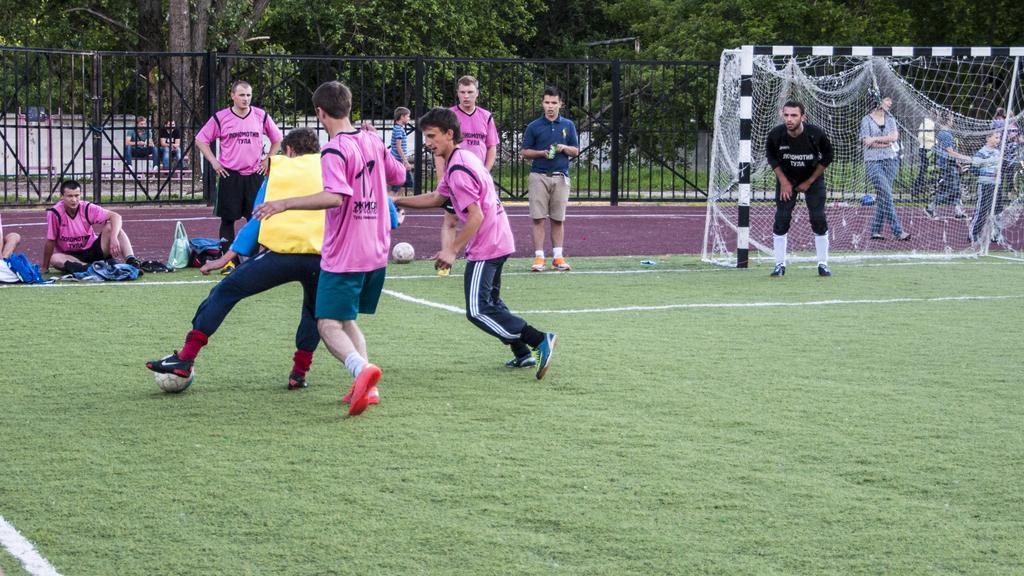What activity are the persons in the image engaged in? The persons in the image are playing football. What is the surface they are playing on? The playing surface is grass. What can be seen at each end of the field? There is a mesh in the image, likely a goal. What can be seen in the background of the image? There are trees and a fence visible in the background. What type of magic is being performed by the players in the image? There is no magic being performed in the image; the persons are playing football. Can you describe the facial expressions of the players in the image? The provided facts do not mention the facial expressions of the players, so we cannot determine if they are smiling or not. 